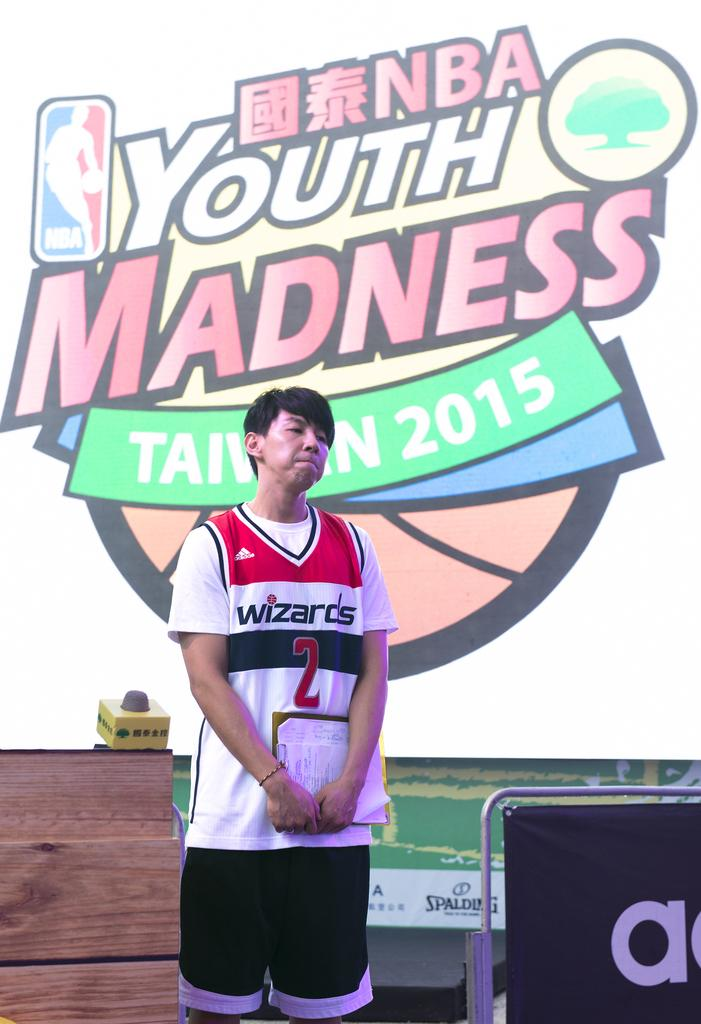What is the main subject of the image? There is a person standing in the image. What is the person holding in his hand? The person is holding an object in his hand. What can be seen beside the person? There is a banner beside the person. What is visible in the background of the image? There is a logo visible in the background of the image. What type of tank can be seen in the image? There is no tank present in the image. How does the pump work in the image? There is no pump present in the image. 